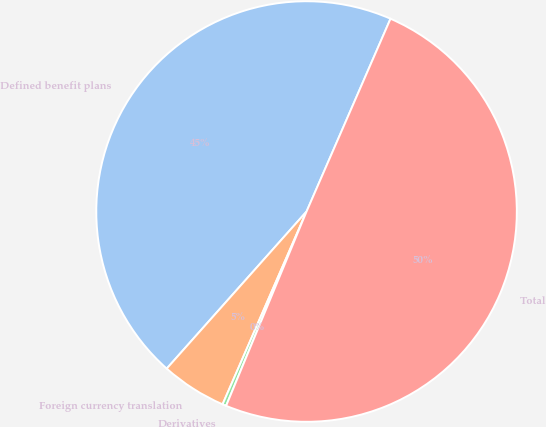Convert chart. <chart><loc_0><loc_0><loc_500><loc_500><pie_chart><fcel>Defined benefit plans<fcel>Foreign currency translation<fcel>Derivatives<fcel>Total<nl><fcel>44.96%<fcel>5.04%<fcel>0.29%<fcel>49.71%<nl></chart> 